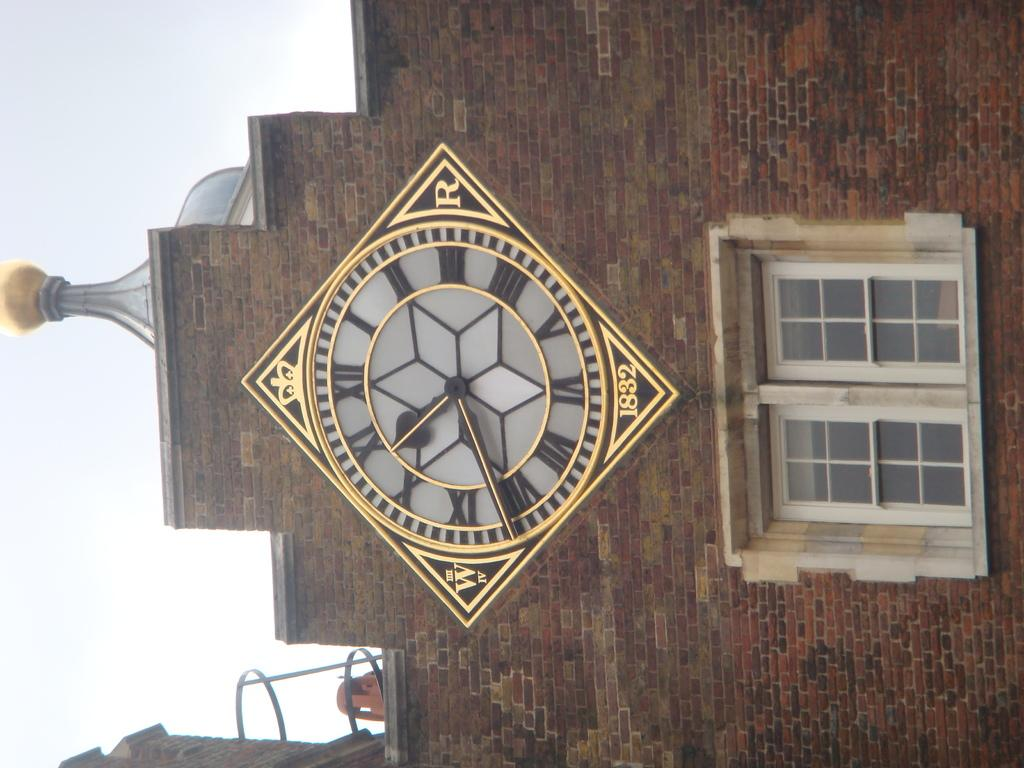What type of structure is visible in the image? There is a wall of a building in the image. What can be seen on the wall of the building? There is a window and a clock in the image. What is the value of the ear depicted in the image? There is no ear present in the image; it only features a wall of a building, a window, and a clock. 